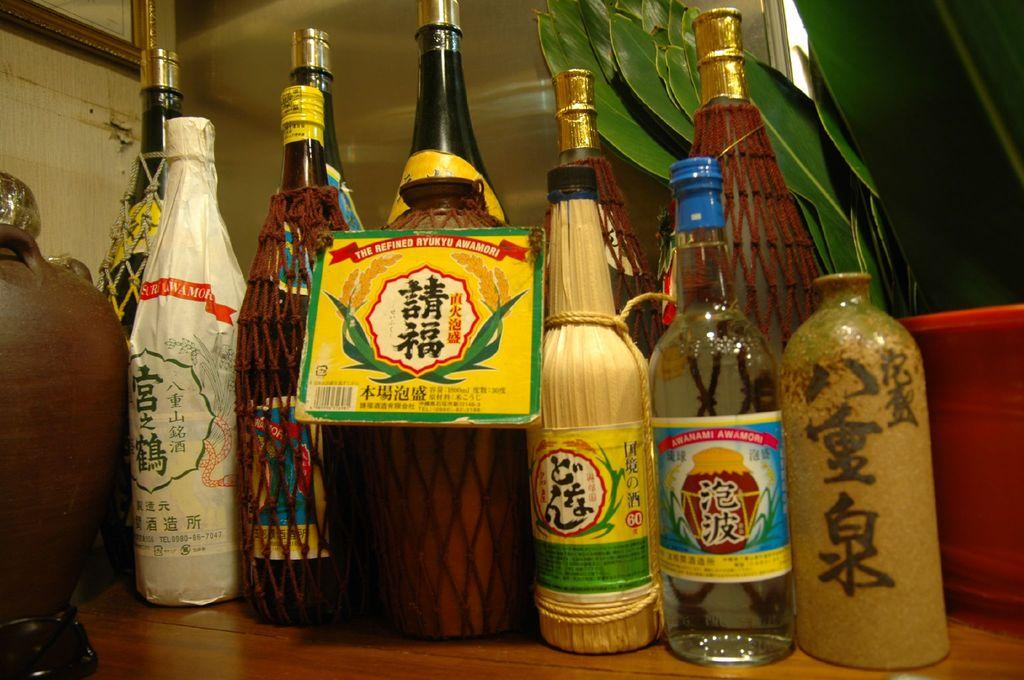Provide a one-sentence caption for the provided image. A group of different sized Asian sauce bottles lined up on a wood table. 